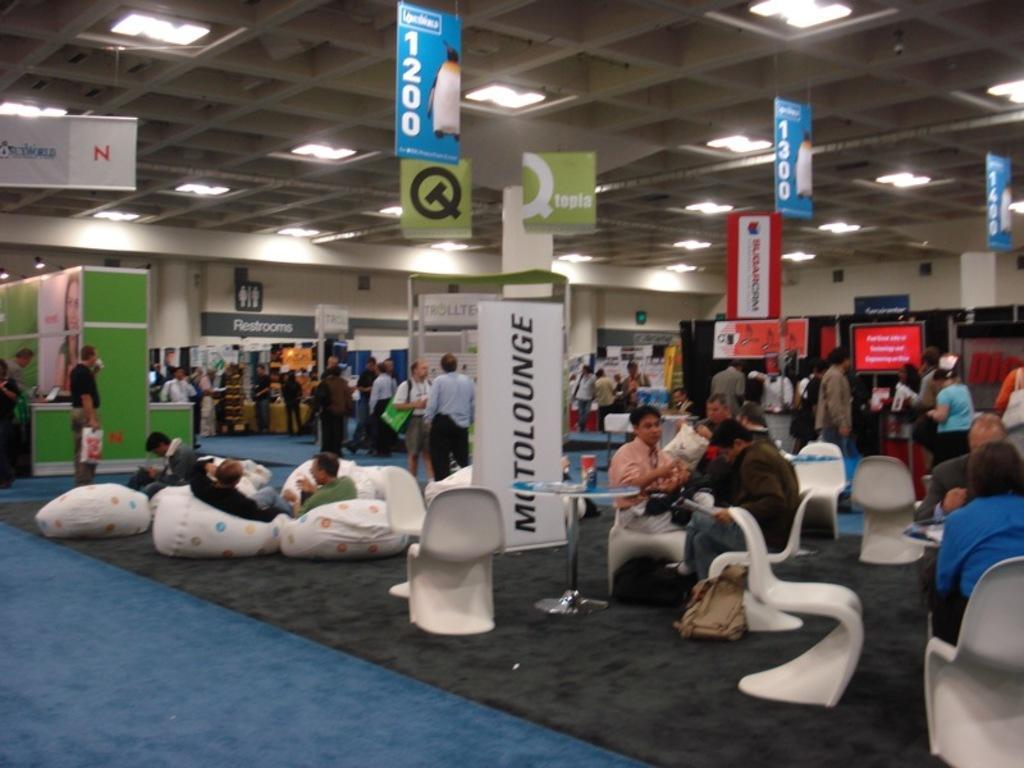Describe this image in one or two sentences. In this image I can see the group of people. Among them some people are sitting in front of the table and some are standing at the shops. And there are many boards,lights in this picture. 